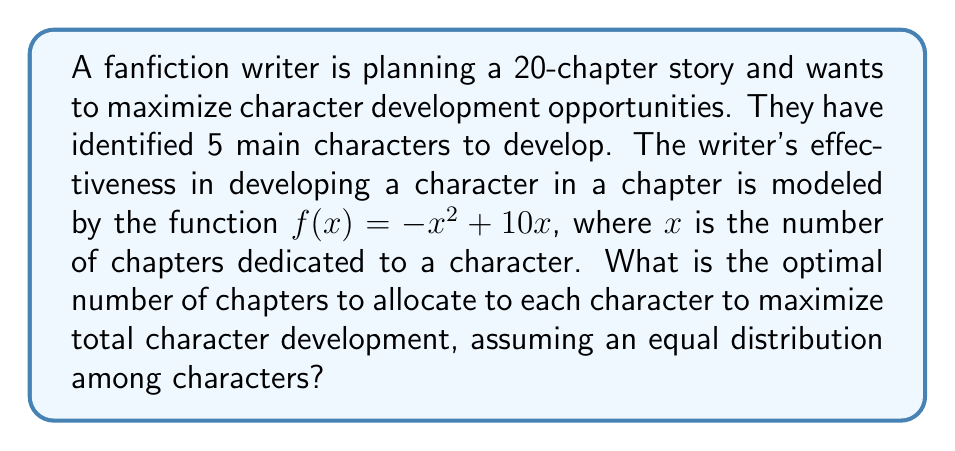Teach me how to tackle this problem. Let's approach this step-by-step:

1) First, we need to set up our optimization problem. We want to maximize the total character development across all 5 characters.

2) Let $x$ be the number of chapters allocated to each character. Since we have 20 chapters in total and 5 characters, we have the constraint:

   $5x = 20$ or $x = 4$

3) The character development function for each character is:

   $f(x) = -x^2 + 10x$

4) To find the maximum of this function, we need to find its derivative and set it to zero:

   $f'(x) = -2x + 10$
   $-2x + 10 = 0$
   $x = 5$

5) This tells us that the optimal number of chapters for maximum development of a single character is 5.

6) However, our constraint from step 2 tells us we can only allocate 4 chapters per character.

7) Since the function is concave (opens downward), and our constraint (4) is less than the unconstrained optimum (5), the constrained optimum will be at $x = 4$.

8) We can verify this by calculating:
   $f(3) = -9 + 30 = 21$
   $f(4) = -16 + 40 = 24$
   $f(5) = -25 + 50 = 25$

   Indeed, 4 is the best integer solution that satisfies our constraint.
Answer: 4 chapters per character 